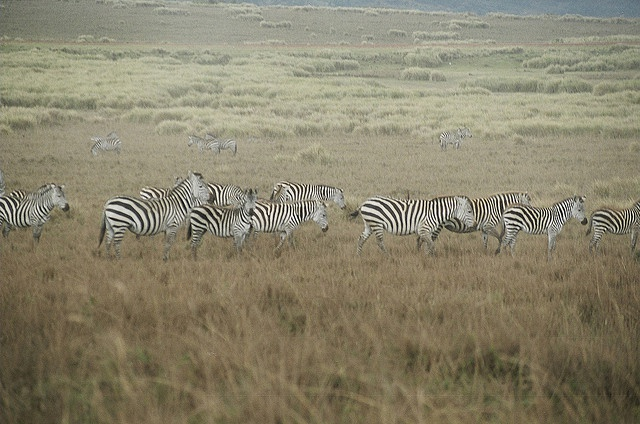Describe the objects in this image and their specific colors. I can see zebra in gray, darkgray, black, and lightgray tones, zebra in gray, darkgray, beige, and black tones, zebra in gray, darkgray, and black tones, zebra in gray, darkgray, and black tones, and zebra in gray, darkgray, and black tones in this image. 